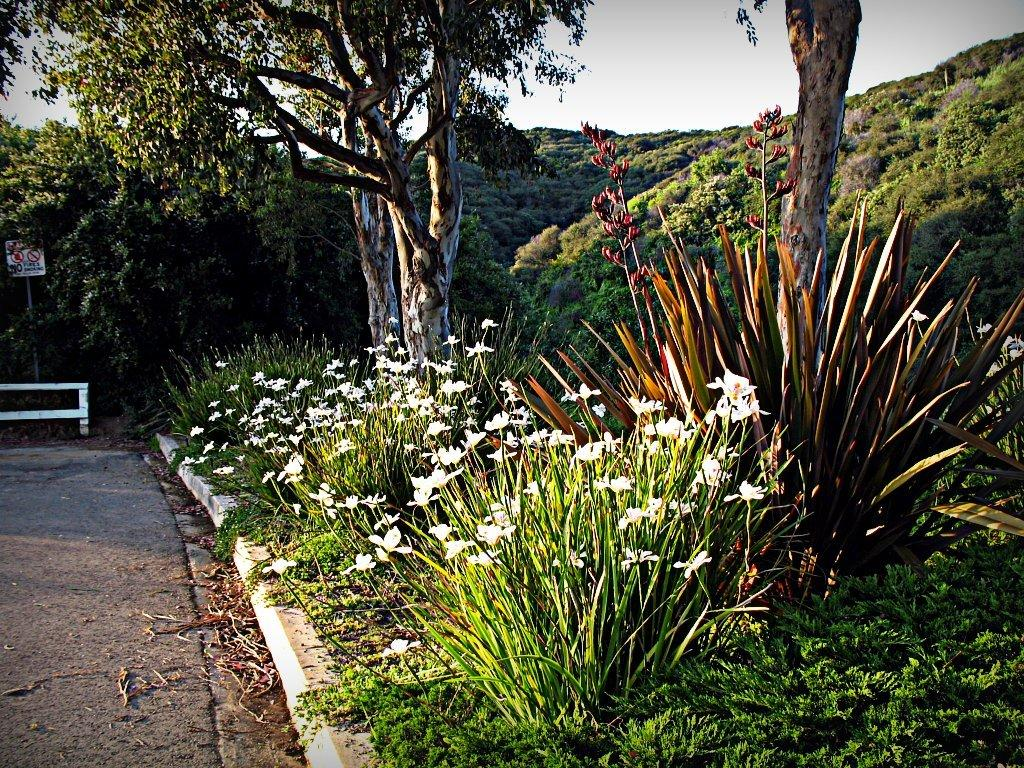What type of plants can be seen in the image? There are plants with flowers in the image. What other vegetation is present in the image? There are trees in the image. What man-made object can be seen in the image? There is a sign board in the image. What is the wooden object in the image used for? The wooden pole in the image is likely used for support or as a marker. What type of ground cover is visible in the image? There is grass visible in the image. What part of the natural environment is visible in the image? The sky is visible in the image. How many legs can be seen on the soda can in the image? There is no soda can present in the image, so it is not possible to determine the number of legs on a soda can. 